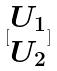Convert formula to latex. <formula><loc_0><loc_0><loc_500><loc_500>[ \begin{matrix} U _ { 1 } \\ U _ { 2 } \end{matrix} ]</formula> 